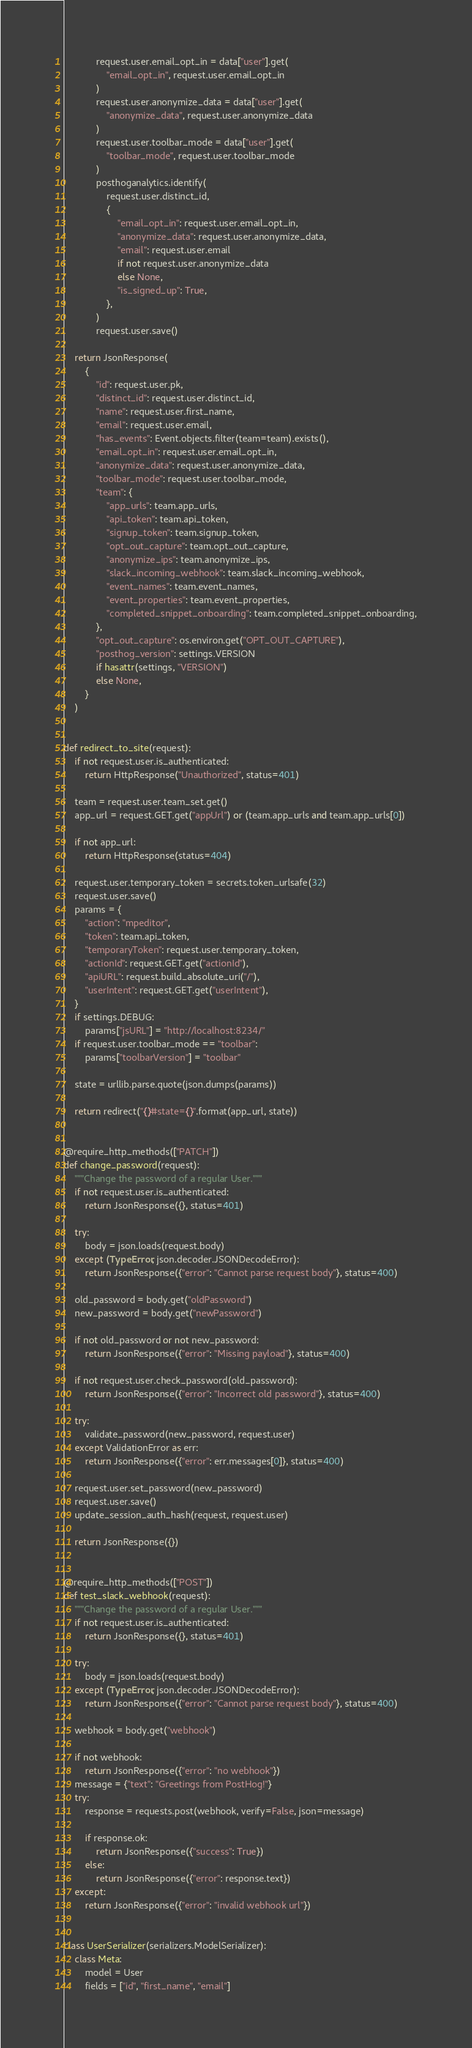<code> <loc_0><loc_0><loc_500><loc_500><_Python_>            request.user.email_opt_in = data["user"].get(
                "email_opt_in", request.user.email_opt_in
            )
            request.user.anonymize_data = data["user"].get(
                "anonymize_data", request.user.anonymize_data
            )
            request.user.toolbar_mode = data["user"].get(
                "toolbar_mode", request.user.toolbar_mode
            )
            posthoganalytics.identify(
                request.user.distinct_id,
                {
                    "email_opt_in": request.user.email_opt_in,
                    "anonymize_data": request.user.anonymize_data,
                    "email": request.user.email
                    if not request.user.anonymize_data
                    else None,
                    "is_signed_up": True,
                },
            )
            request.user.save()

    return JsonResponse(
        {
            "id": request.user.pk,
            "distinct_id": request.user.distinct_id,
            "name": request.user.first_name,
            "email": request.user.email,
            "has_events": Event.objects.filter(team=team).exists(),
            "email_opt_in": request.user.email_opt_in,
            "anonymize_data": request.user.anonymize_data,
            "toolbar_mode": request.user.toolbar_mode,
            "team": {
                "app_urls": team.app_urls,
                "api_token": team.api_token,
                "signup_token": team.signup_token,
                "opt_out_capture": team.opt_out_capture,
                "anonymize_ips": team.anonymize_ips,
                "slack_incoming_webhook": team.slack_incoming_webhook,
                "event_names": team.event_names,
                "event_properties": team.event_properties,
                "completed_snippet_onboarding": team.completed_snippet_onboarding,
            },
            "opt_out_capture": os.environ.get("OPT_OUT_CAPTURE"),
            "posthog_version": settings.VERSION
            if hasattr(settings, "VERSION")
            else None,
        }
    )


def redirect_to_site(request):
    if not request.user.is_authenticated:
        return HttpResponse("Unauthorized", status=401)

    team = request.user.team_set.get()
    app_url = request.GET.get("appUrl") or (team.app_urls and team.app_urls[0])

    if not app_url:
        return HttpResponse(status=404)

    request.user.temporary_token = secrets.token_urlsafe(32)
    request.user.save()
    params = {
        "action": "mpeditor",
        "token": team.api_token,
        "temporaryToken": request.user.temporary_token,
        "actionId": request.GET.get("actionId"),
        "apiURL": request.build_absolute_uri("/"),
        "userIntent": request.GET.get("userIntent"),
    }
    if settings.DEBUG:
        params["jsURL"] = "http://localhost:8234/"
    if request.user.toolbar_mode == "toolbar":
        params["toolbarVersion"] = "toolbar"

    state = urllib.parse.quote(json.dumps(params))

    return redirect("{}#state={}".format(app_url, state))


@require_http_methods(["PATCH"])
def change_password(request):
    """Change the password of a regular User."""
    if not request.user.is_authenticated:
        return JsonResponse({}, status=401)

    try:
        body = json.loads(request.body)
    except (TypeError, json.decoder.JSONDecodeError):
        return JsonResponse({"error": "Cannot parse request body"}, status=400)

    old_password = body.get("oldPassword")
    new_password = body.get("newPassword")

    if not old_password or not new_password:
        return JsonResponse({"error": "Missing payload"}, status=400)

    if not request.user.check_password(old_password):
        return JsonResponse({"error": "Incorrect old password"}, status=400)

    try:
        validate_password(new_password, request.user)
    except ValidationError as err:
        return JsonResponse({"error": err.messages[0]}, status=400)

    request.user.set_password(new_password)
    request.user.save()
    update_session_auth_hash(request, request.user)

    return JsonResponse({})


@require_http_methods(["POST"])
def test_slack_webhook(request):
    """Change the password of a regular User."""
    if not request.user.is_authenticated:
        return JsonResponse({}, status=401)

    try:
        body = json.loads(request.body)
    except (TypeError, json.decoder.JSONDecodeError):
        return JsonResponse({"error": "Cannot parse request body"}, status=400)

    webhook = body.get("webhook")

    if not webhook:
        return JsonResponse({"error": "no webhook"})
    message = {"text": "Greetings from PostHog!"}
    try:
        response = requests.post(webhook, verify=False, json=message)

        if response.ok:
            return JsonResponse({"success": True})
        else:
            return JsonResponse({"error": response.text})
    except:
        return JsonResponse({"error": "invalid webhook url"})


class UserSerializer(serializers.ModelSerializer):
    class Meta:
        model = User
        fields = ["id", "first_name", "email"]
</code> 